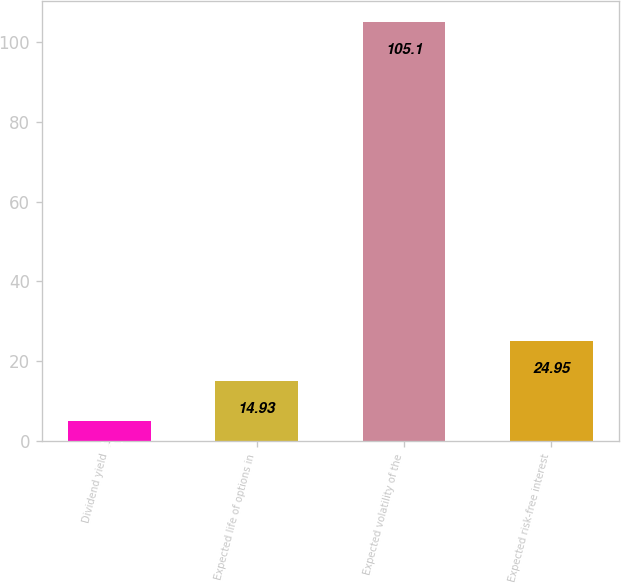Convert chart to OTSL. <chart><loc_0><loc_0><loc_500><loc_500><bar_chart><fcel>Dividend yield<fcel>Expected life of options in<fcel>Expected volatility of the<fcel>Expected risk-free interest<nl><fcel>4.91<fcel>14.93<fcel>105.1<fcel>24.95<nl></chart> 